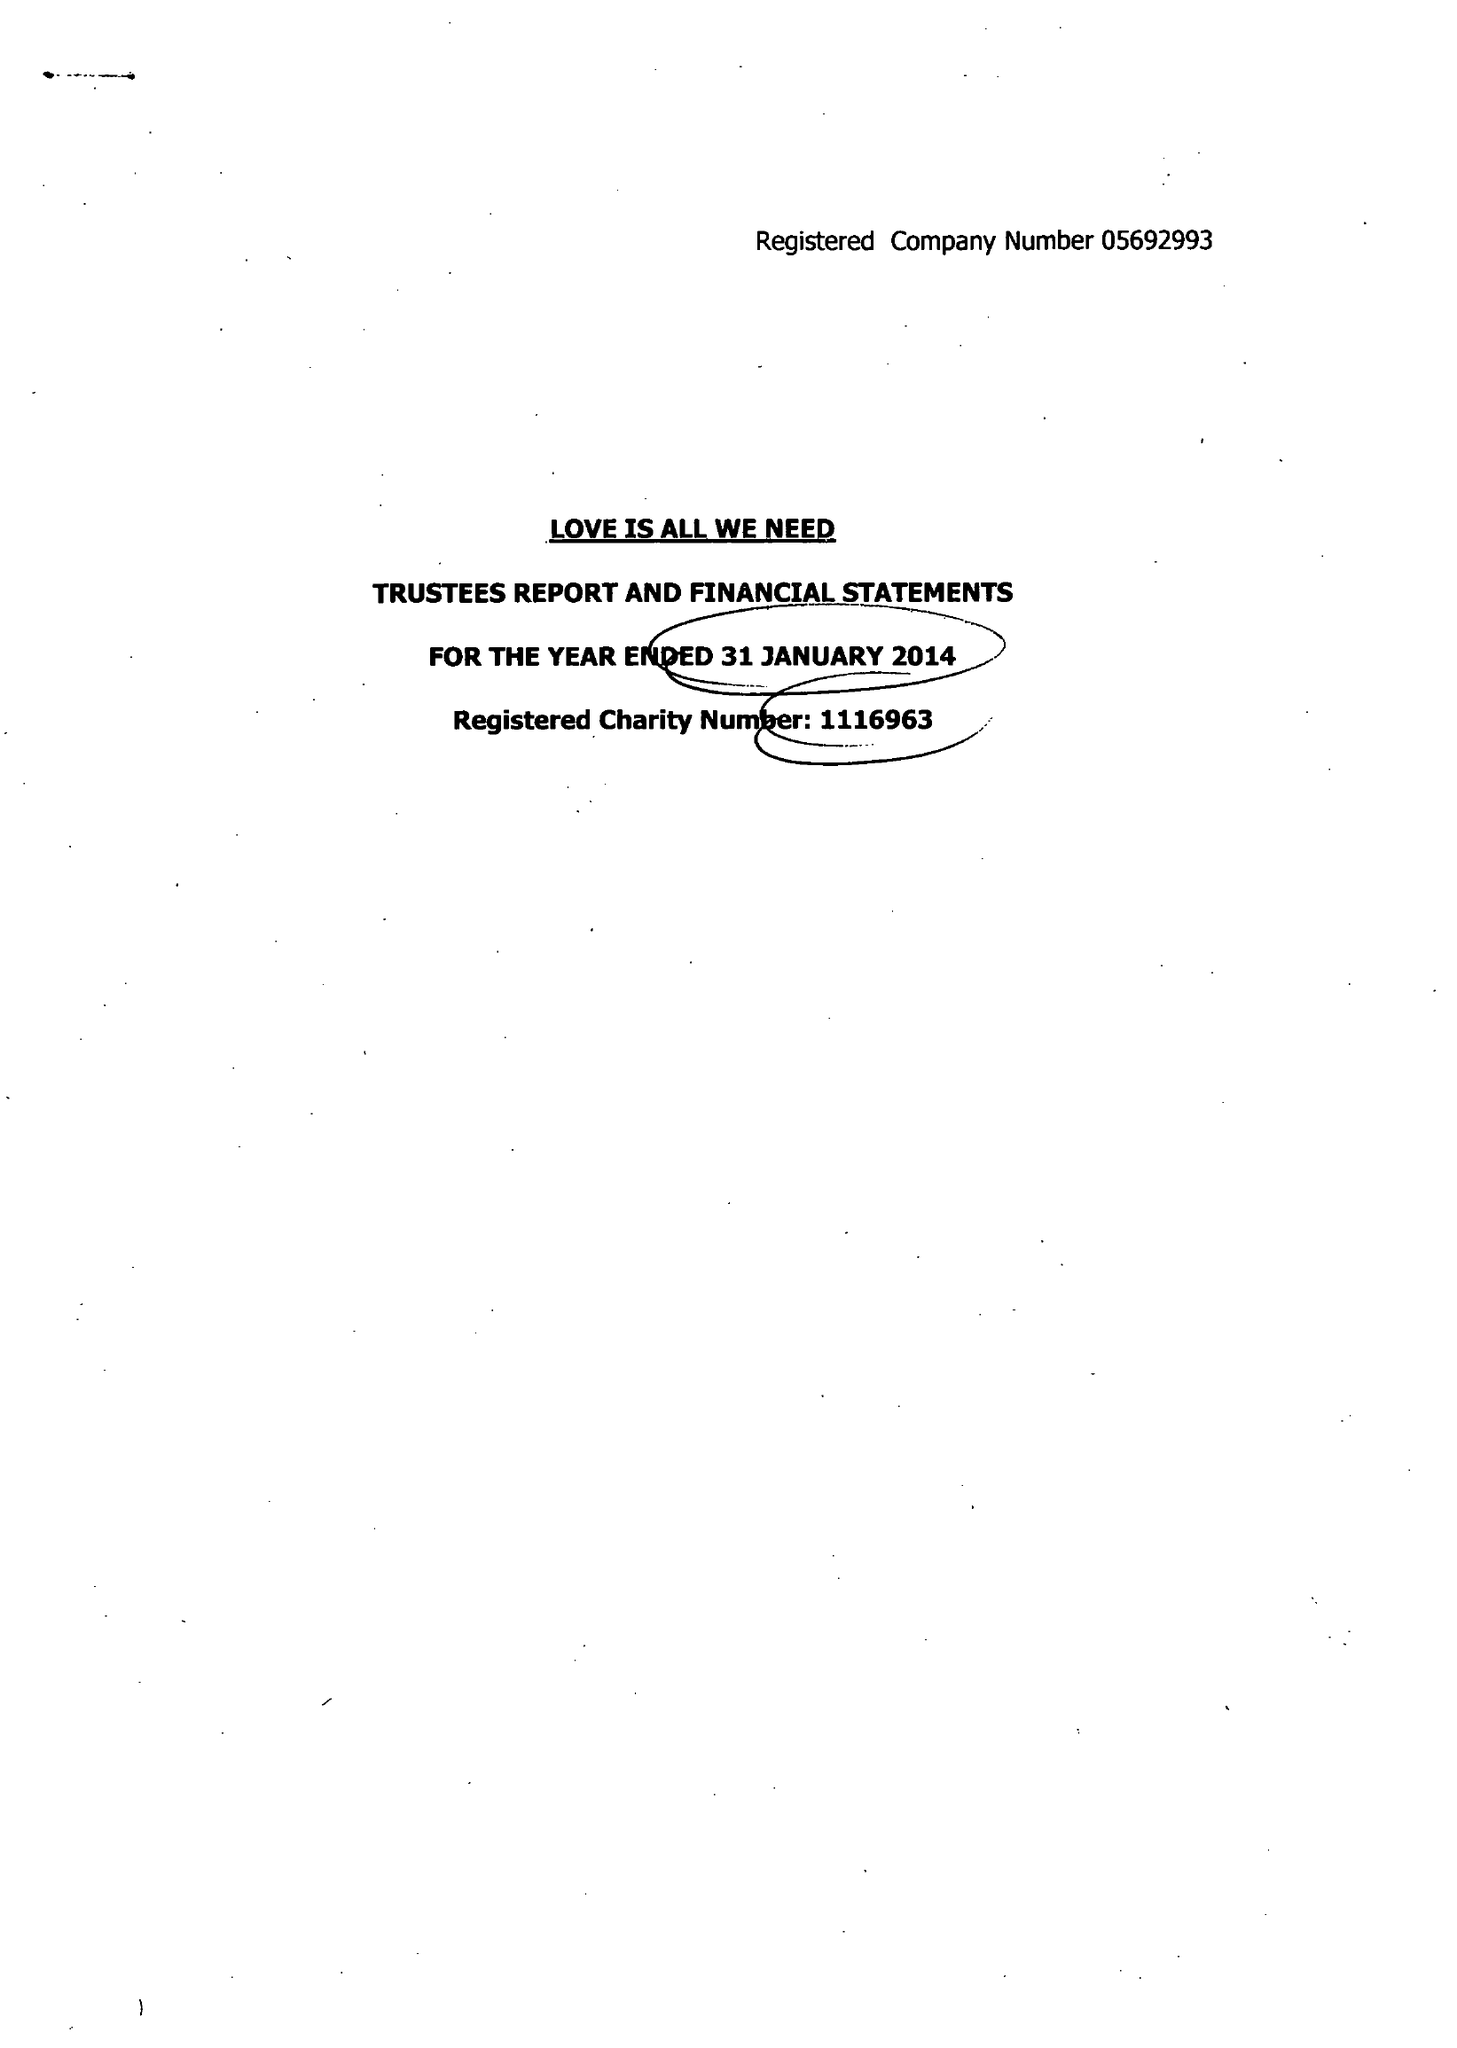What is the value for the address__post_town?
Answer the question using a single word or phrase. HOVE 